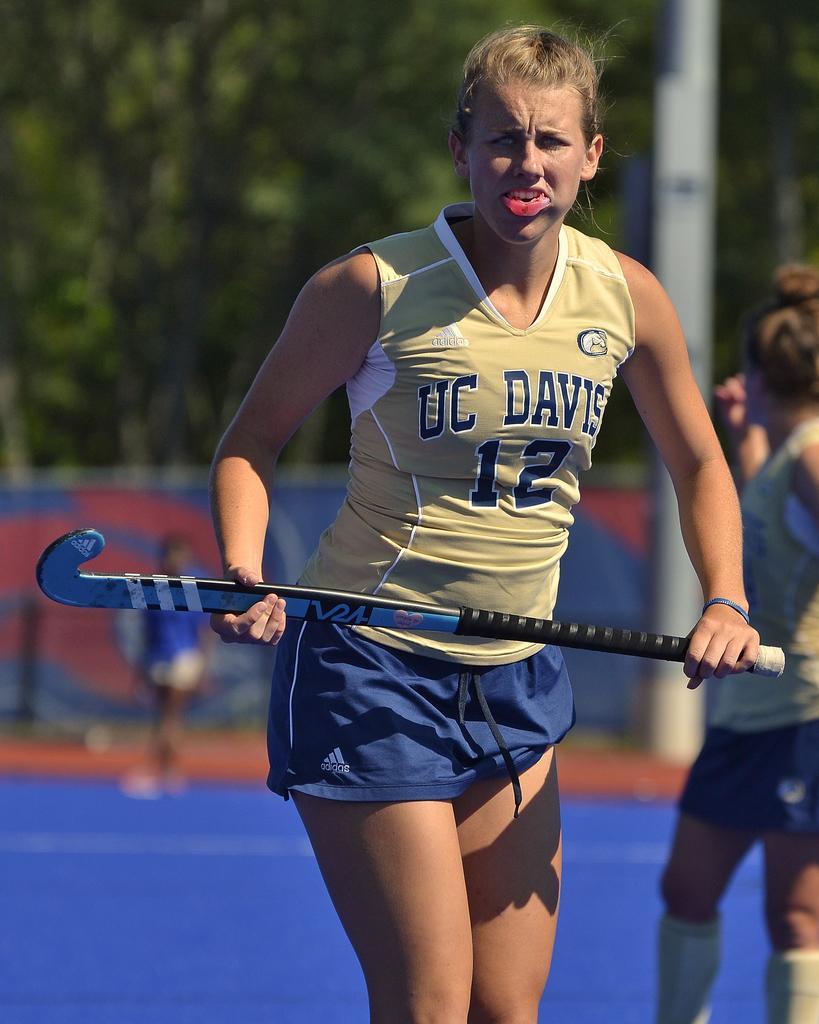In one or two sentences, can you explain what this image depicts? In this image, we can see a few people. Among them, we can see a person holding an object. We can see the ground and the blurred background. 